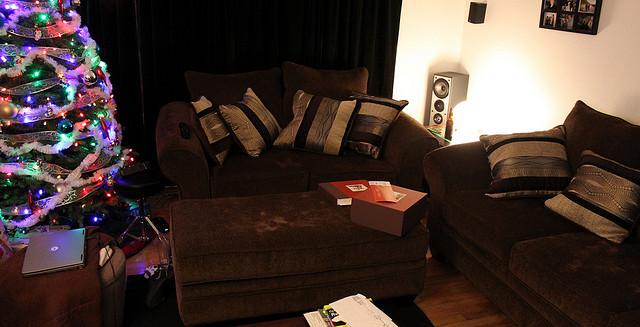What holiday do you think of?
Quick response, please. Christmas. What color laptop is in this picture?
Quick response, please. Gray. How many pillows are on the furniture, excluding the ones that are part of the furniture?
Concise answer only. 6. 